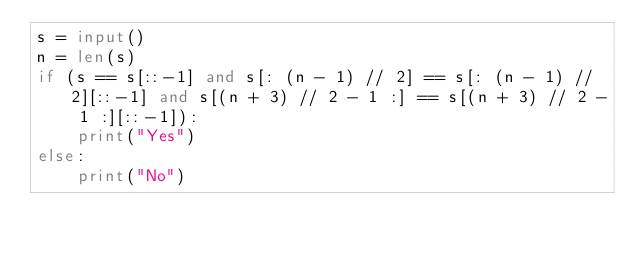<code> <loc_0><loc_0><loc_500><loc_500><_Python_>s = input()
n = len(s)
if (s == s[::-1] and s[: (n - 1) // 2] == s[: (n - 1) // 2][::-1] and s[(n + 3) // 2 - 1 :] == s[(n + 3) // 2 - 1 :][::-1]):
    print("Yes")
else:
    print("No")</code> 